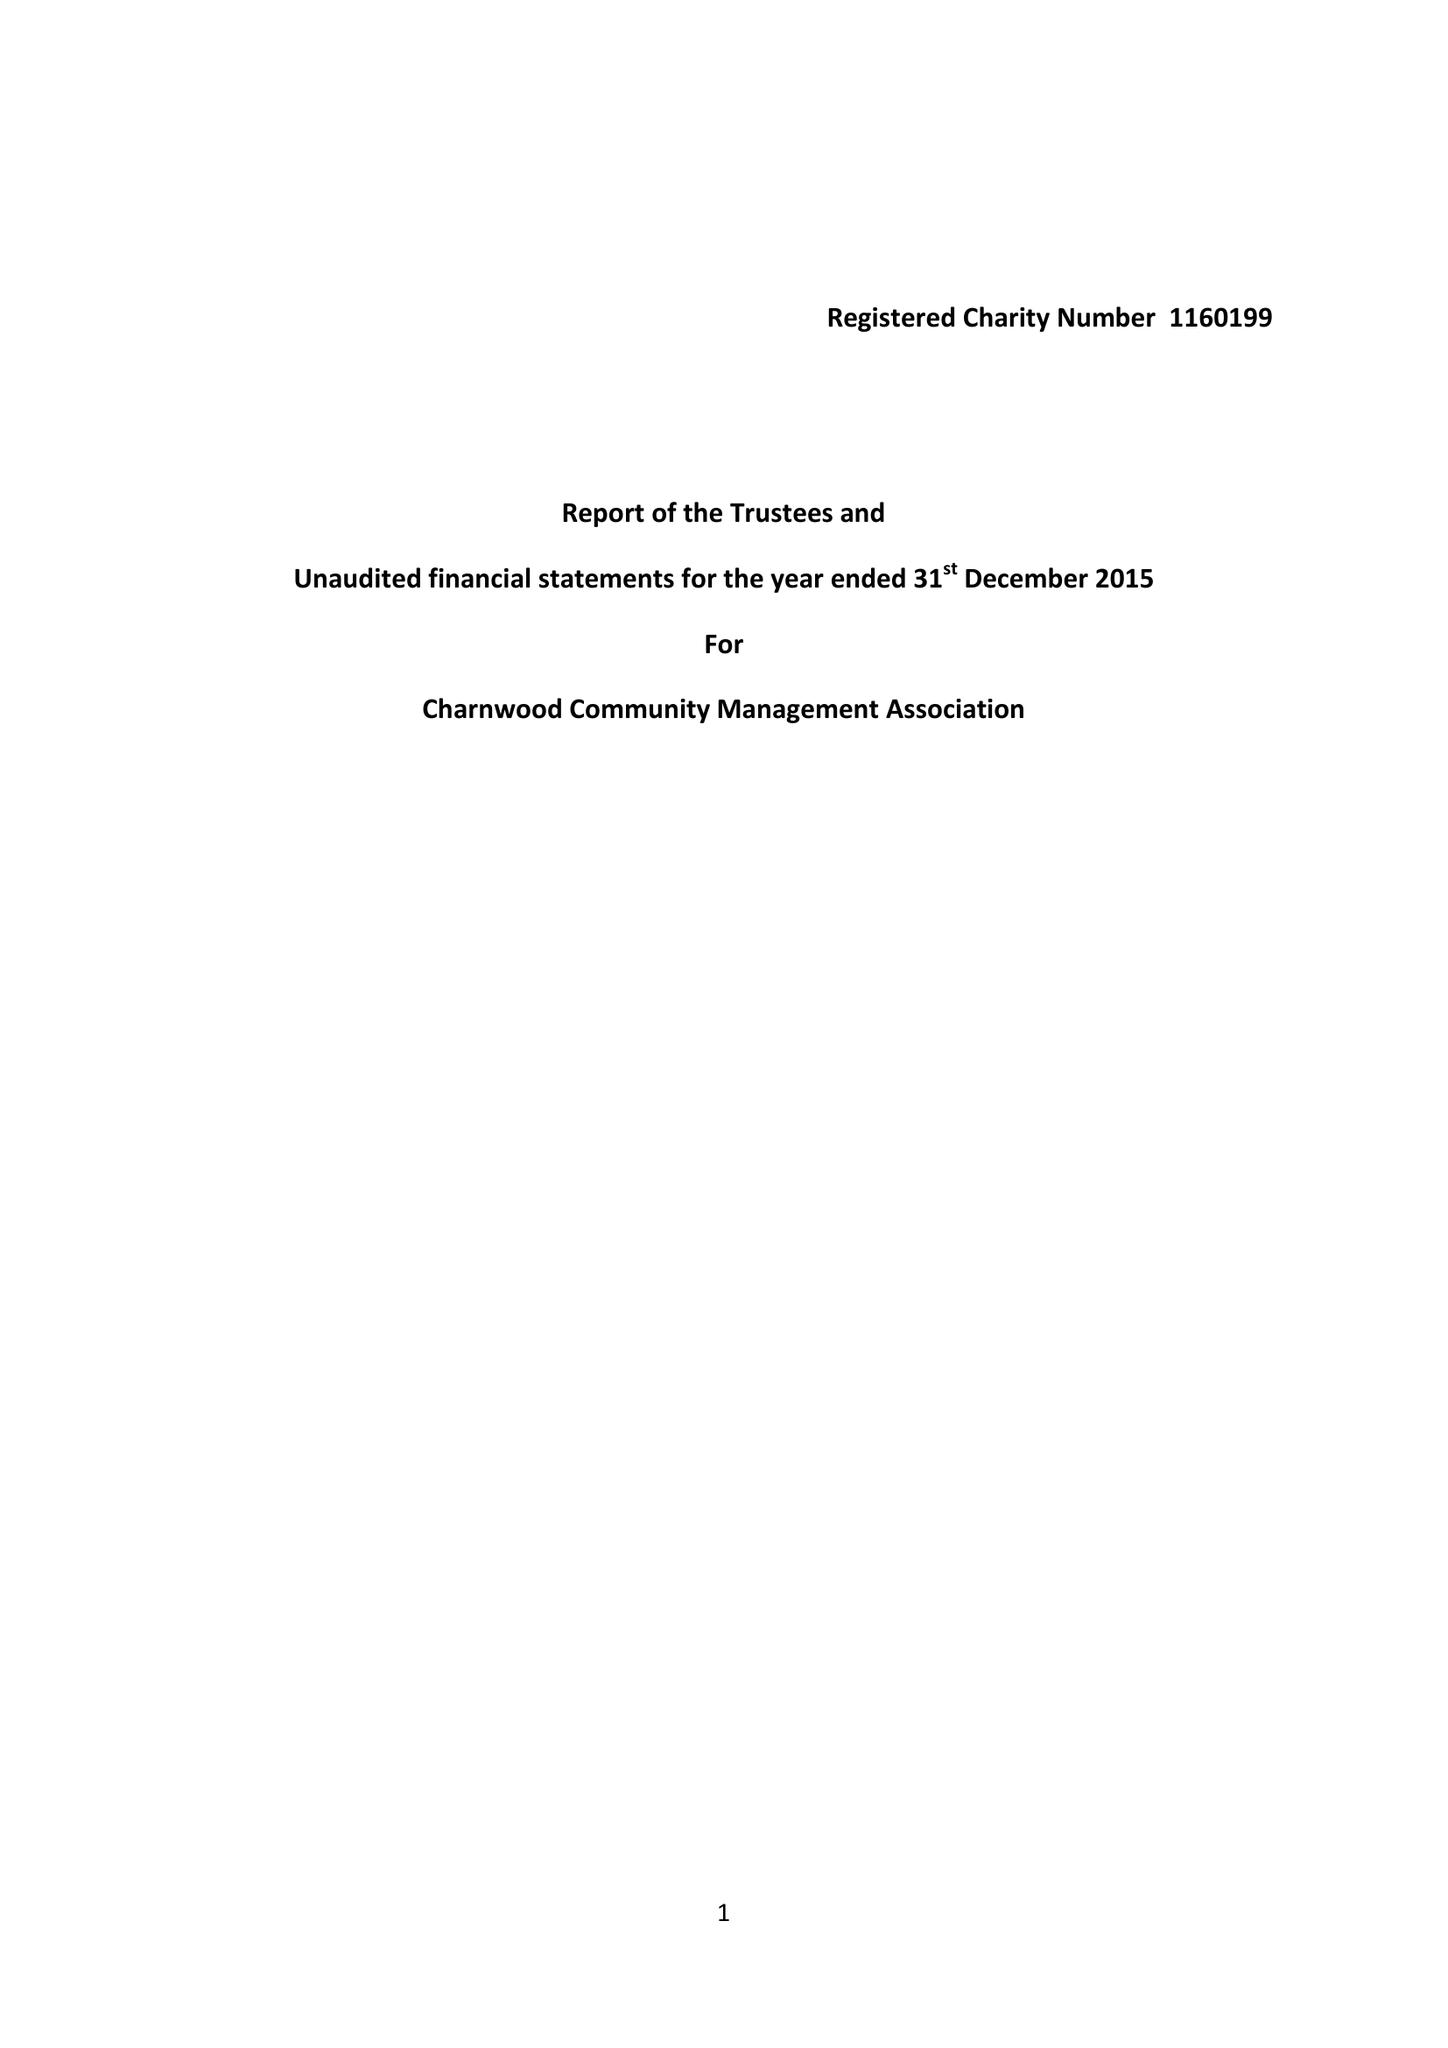What is the value for the charity_name?
Answer the question using a single word or phrase. Charnwood Community Management Association 